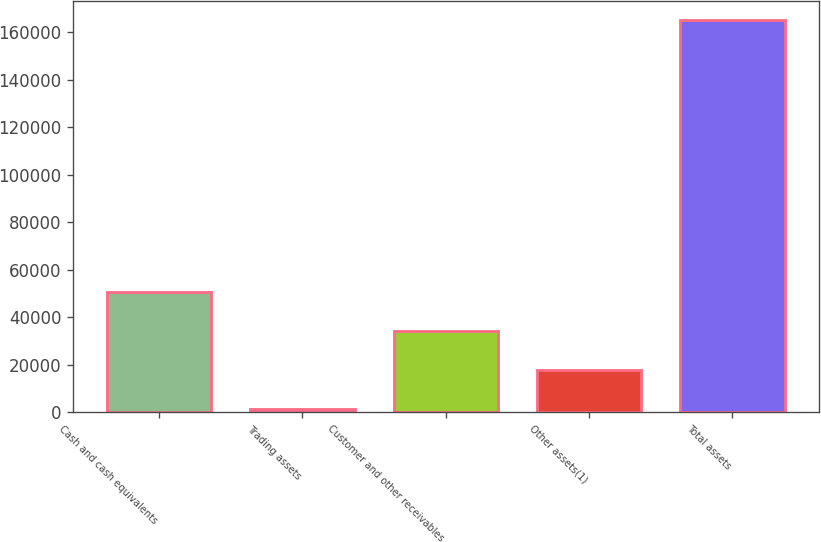<chart> <loc_0><loc_0><loc_500><loc_500><bar_chart><fcel>Cash and cash equivalents<fcel>Trading assets<fcel>Customer and other receivables<fcel>Other assets(1)<fcel>Total assets<nl><fcel>50454.1<fcel>1300<fcel>34069.4<fcel>17684.7<fcel>165147<nl></chart> 